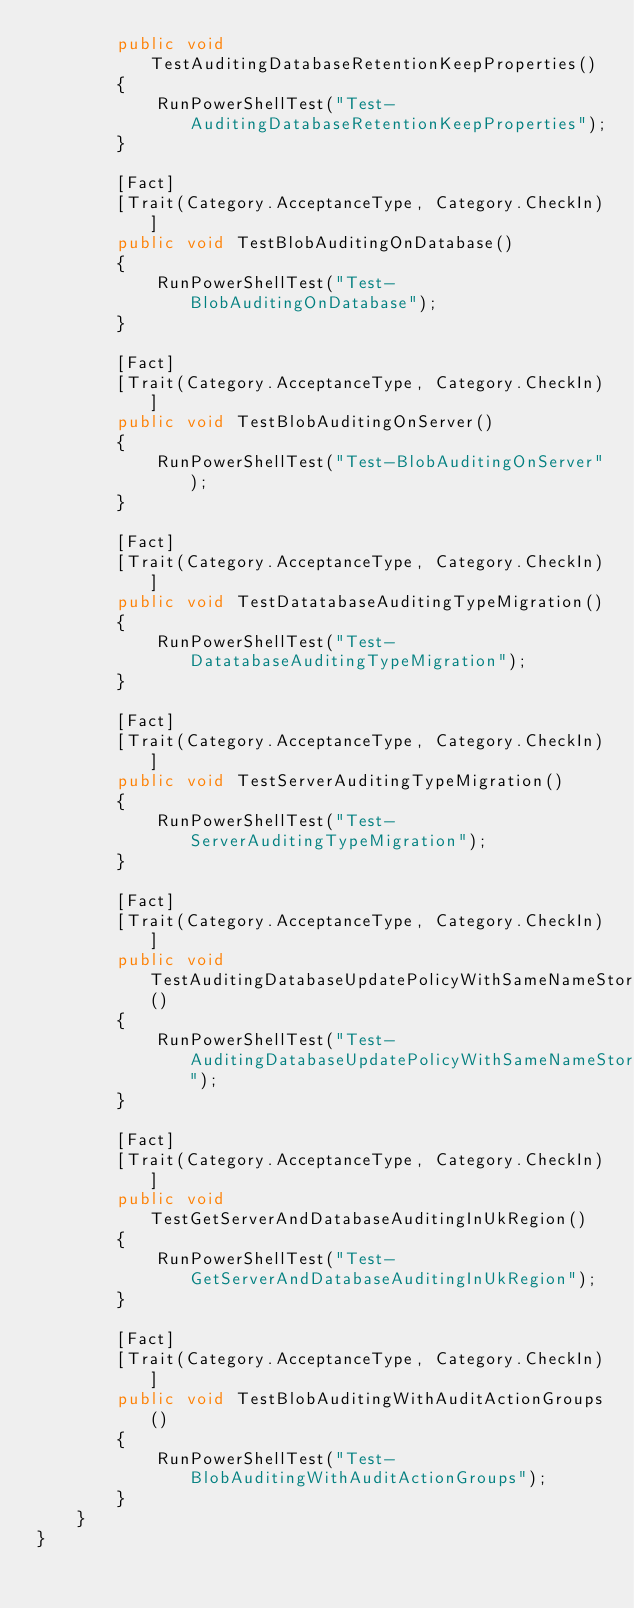Convert code to text. <code><loc_0><loc_0><loc_500><loc_500><_C#_>        public void TestAuditingDatabaseRetentionKeepProperties()
        {
            RunPowerShellTest("Test-AuditingDatabaseRetentionKeepProperties");
        }

        [Fact]
        [Trait(Category.AcceptanceType, Category.CheckIn)]
        public void TestBlobAuditingOnDatabase()
        {
            RunPowerShellTest("Test-BlobAuditingOnDatabase");
        }

        [Fact]
        [Trait(Category.AcceptanceType, Category.CheckIn)]
        public void TestBlobAuditingOnServer()
        {
            RunPowerShellTest("Test-BlobAuditingOnServer");
        }

        [Fact]
        [Trait(Category.AcceptanceType, Category.CheckIn)]
        public void TestDatatabaseAuditingTypeMigration()
        {
            RunPowerShellTest("Test-DatatabaseAuditingTypeMigration");
        }

        [Fact]
        [Trait(Category.AcceptanceType, Category.CheckIn)]
        public void TestServerAuditingTypeMigration()
        {
            RunPowerShellTest("Test-ServerAuditingTypeMigration");
        }

        [Fact]
        [Trait(Category.AcceptanceType, Category.CheckIn)]
        public void TestAuditingDatabaseUpdatePolicyWithSameNameStorageOnDifferentRegion()
        {
            RunPowerShellTest("Test-AuditingDatabaseUpdatePolicyWithSameNameStorageOnDifferentRegion");
        }

        [Fact]
        [Trait(Category.AcceptanceType, Category.CheckIn)]
        public void TestGetServerAndDatabaseAuditingInUkRegion()
        {
            RunPowerShellTest("Test-GetServerAndDatabaseAuditingInUkRegion");
        }

        [Fact]
        [Trait(Category.AcceptanceType, Category.CheckIn)]
        public void TestBlobAuditingWithAuditActionGroups()
        {
            RunPowerShellTest("Test-BlobAuditingWithAuditActionGroups");
        }
    }
}
</code> 